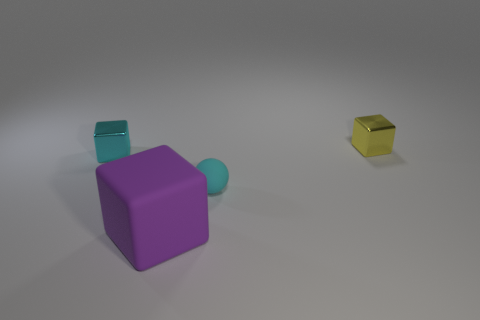Add 2 tiny purple things. How many objects exist? 6 Subtract all cubes. How many objects are left? 1 Add 4 tiny cyan matte spheres. How many tiny cyan matte spheres exist? 5 Subtract 0 brown blocks. How many objects are left? 4 Subtract all big purple things. Subtract all tiny things. How many objects are left? 0 Add 2 rubber cubes. How many rubber cubes are left? 3 